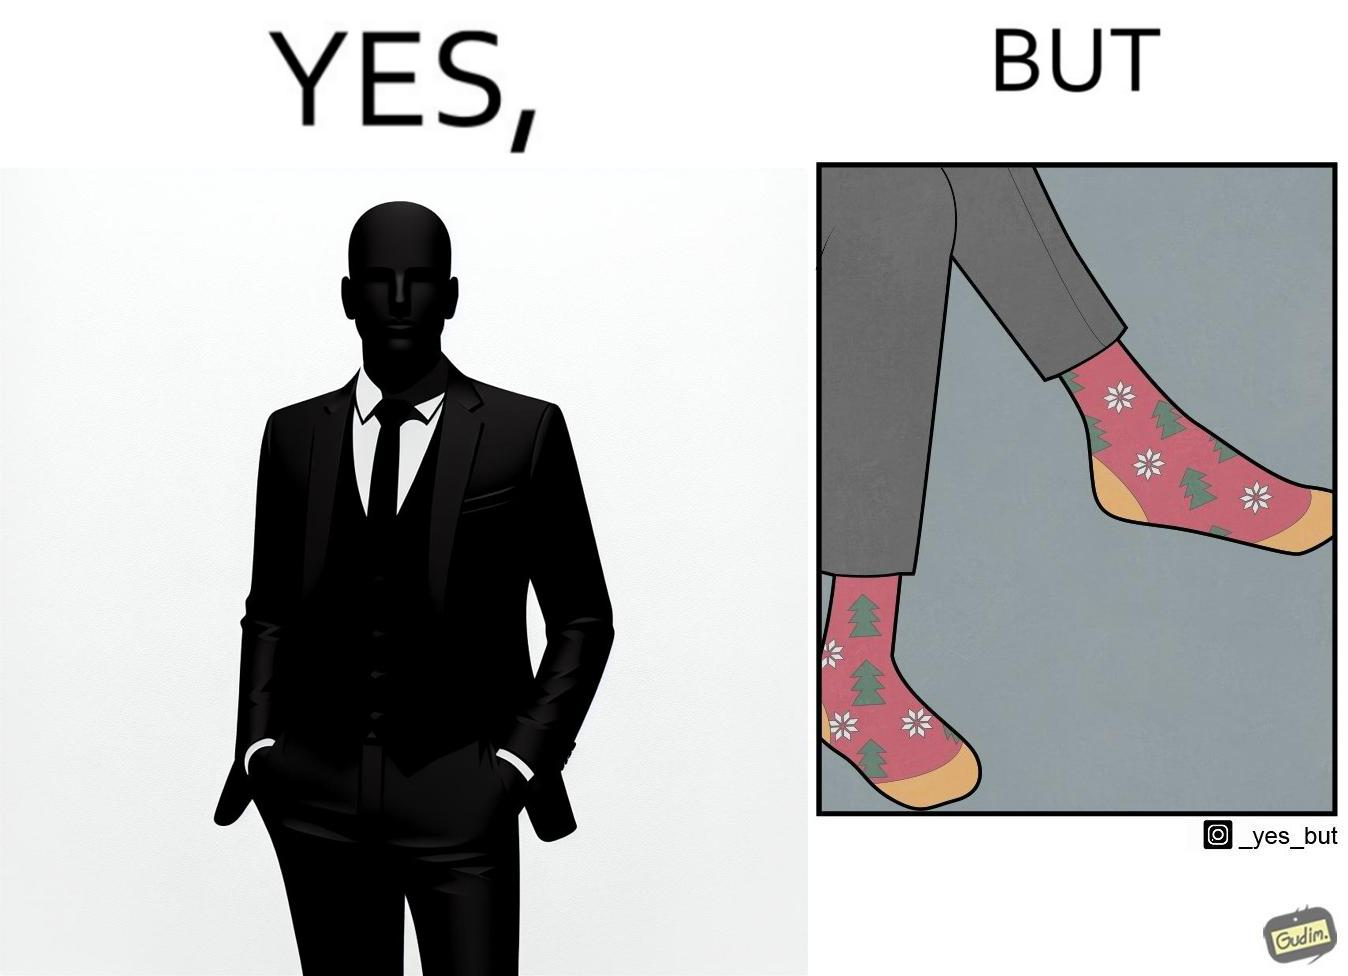What is shown in this image? The image is ironical, as the person wearing a formal black suit and pants, is wearing colorful socks, probably due to the reason that socks are not visible while wearing shoes, and hence, do not need to be formal. 